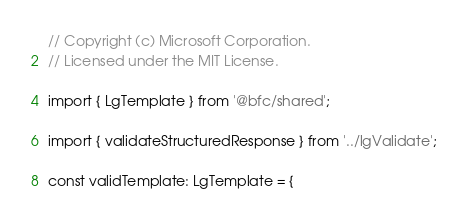<code> <loc_0><loc_0><loc_500><loc_500><_TypeScript_>// Copyright (c) Microsoft Corporation.
// Licensed under the MIT License.

import { LgTemplate } from '@bfc/shared';

import { validateStructuredResponse } from '../lgValidate';

const validTemplate: LgTemplate = {</code> 